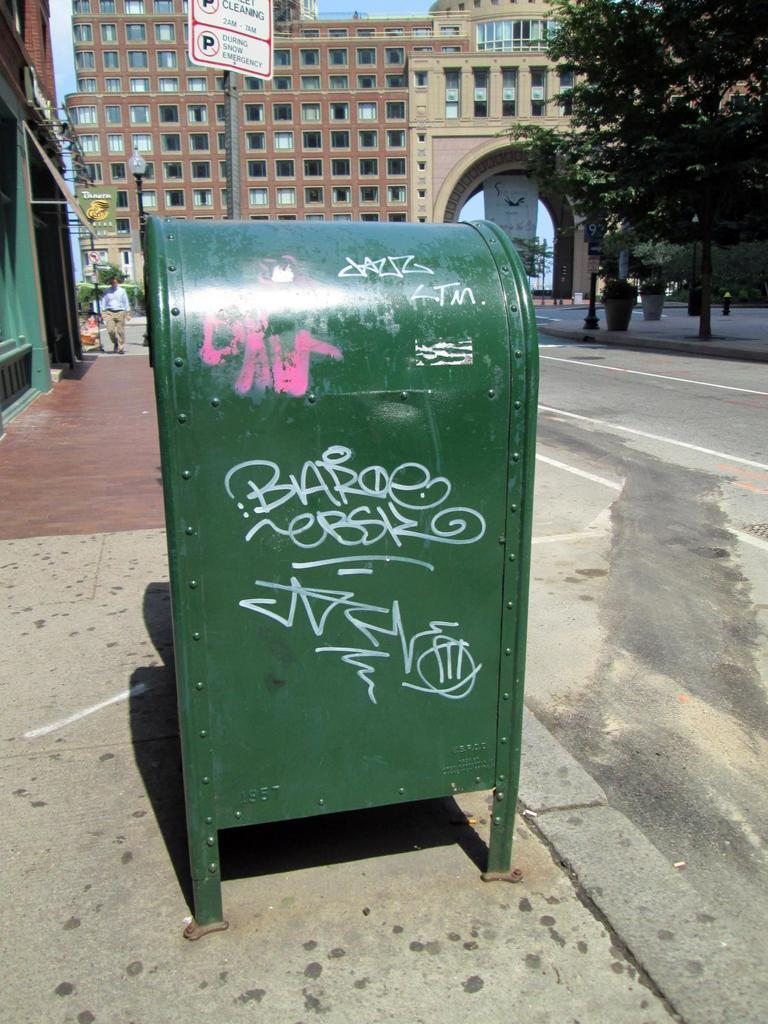<image>
Render a clear and concise summary of the photo. The green mailbox is graffiti tagged Baroe ebsy. 